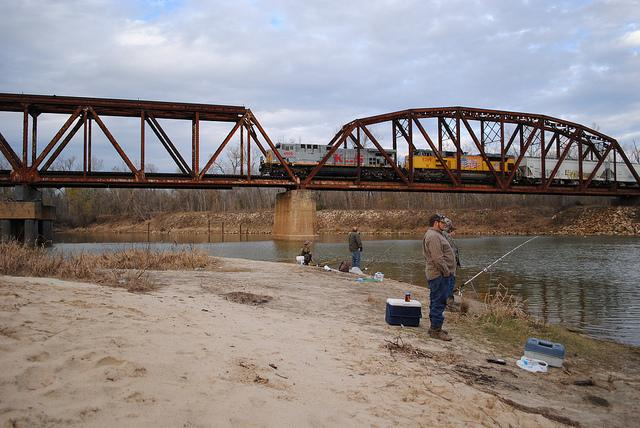What do the men hope to bring home?

Choices:
A) car
B) dog
C) fish
D) women fish 